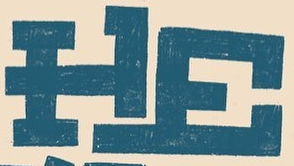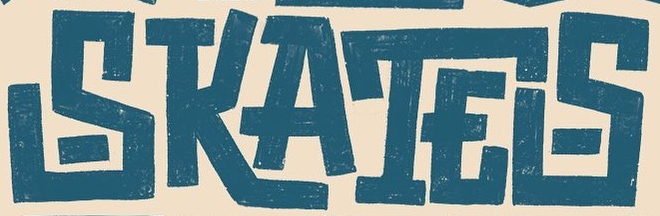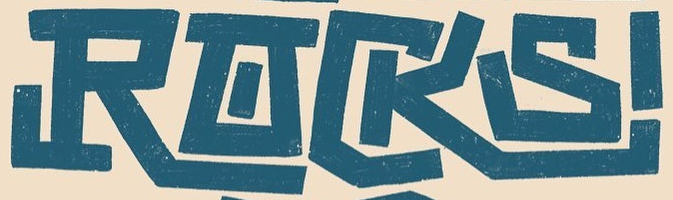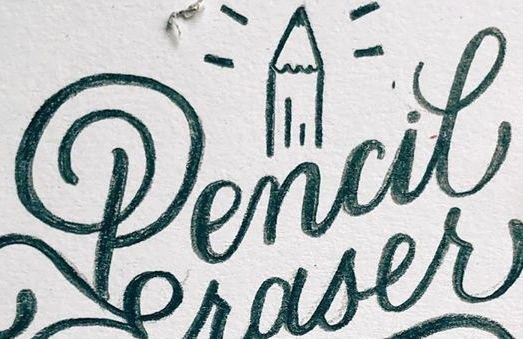Read the text content from these images in order, separated by a semicolon. HE; SKATES; RACKS; Pencil 